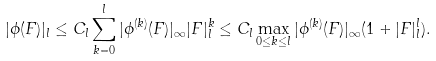<formula> <loc_0><loc_0><loc_500><loc_500>| \phi ( F ) | _ { l } \leq C _ { l } \sum _ { k = 0 } ^ { l } | \phi ^ { ( k ) } ( F ) | _ { \infty } | F | _ { l } ^ { k } \leq C _ { l } \max _ { 0 \leq k \leq l } | \phi ^ { ( k ) } ( F ) | _ { \infty } ( 1 + | F | _ { l } ^ { l } ) .</formula> 